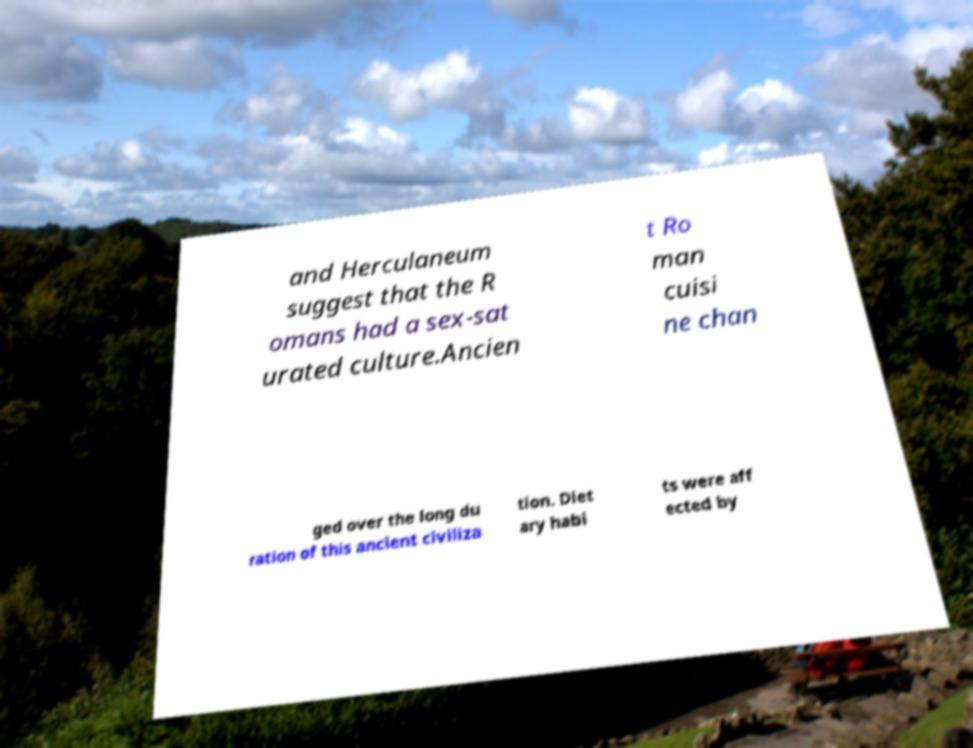Could you extract and type out the text from this image? and Herculaneum suggest that the R omans had a sex-sat urated culture.Ancien t Ro man cuisi ne chan ged over the long du ration of this ancient civiliza tion. Diet ary habi ts were aff ected by 